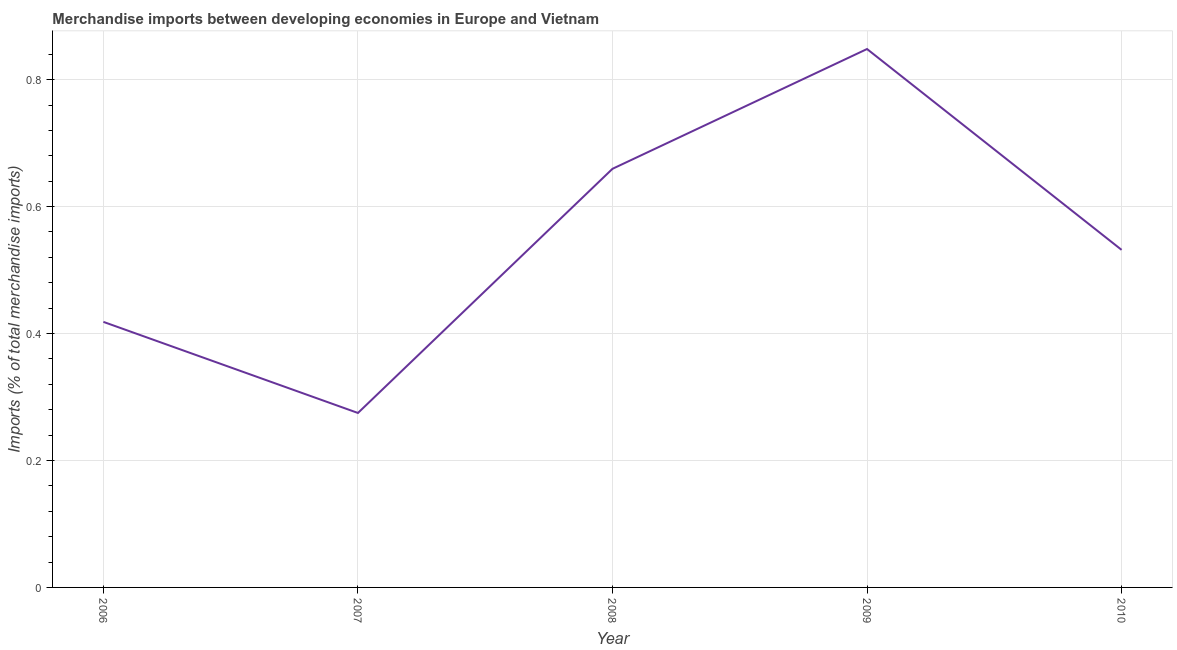What is the merchandise imports in 2009?
Make the answer very short. 0.85. Across all years, what is the maximum merchandise imports?
Give a very brief answer. 0.85. Across all years, what is the minimum merchandise imports?
Make the answer very short. 0.27. What is the sum of the merchandise imports?
Provide a short and direct response. 2.73. What is the difference between the merchandise imports in 2006 and 2009?
Give a very brief answer. -0.43. What is the average merchandise imports per year?
Your answer should be compact. 0.55. What is the median merchandise imports?
Your answer should be very brief. 0.53. In how many years, is the merchandise imports greater than 0.7200000000000001 %?
Offer a terse response. 1. Do a majority of the years between 2009 and 2010 (inclusive) have merchandise imports greater than 0.68 %?
Ensure brevity in your answer.  No. What is the ratio of the merchandise imports in 2008 to that in 2010?
Offer a terse response. 1.24. Is the difference between the merchandise imports in 2006 and 2007 greater than the difference between any two years?
Make the answer very short. No. What is the difference between the highest and the second highest merchandise imports?
Provide a short and direct response. 0.19. Is the sum of the merchandise imports in 2006 and 2010 greater than the maximum merchandise imports across all years?
Your answer should be very brief. Yes. What is the difference between the highest and the lowest merchandise imports?
Make the answer very short. 0.57. How many lines are there?
Make the answer very short. 1. How many years are there in the graph?
Provide a short and direct response. 5. Are the values on the major ticks of Y-axis written in scientific E-notation?
Make the answer very short. No. Does the graph contain any zero values?
Your answer should be very brief. No. What is the title of the graph?
Your response must be concise. Merchandise imports between developing economies in Europe and Vietnam. What is the label or title of the Y-axis?
Your answer should be compact. Imports (% of total merchandise imports). What is the Imports (% of total merchandise imports) in 2006?
Your answer should be compact. 0.42. What is the Imports (% of total merchandise imports) in 2007?
Offer a very short reply. 0.27. What is the Imports (% of total merchandise imports) in 2008?
Give a very brief answer. 0.66. What is the Imports (% of total merchandise imports) in 2009?
Ensure brevity in your answer.  0.85. What is the Imports (% of total merchandise imports) in 2010?
Provide a succinct answer. 0.53. What is the difference between the Imports (% of total merchandise imports) in 2006 and 2007?
Your response must be concise. 0.14. What is the difference between the Imports (% of total merchandise imports) in 2006 and 2008?
Make the answer very short. -0.24. What is the difference between the Imports (% of total merchandise imports) in 2006 and 2009?
Make the answer very short. -0.43. What is the difference between the Imports (% of total merchandise imports) in 2006 and 2010?
Provide a short and direct response. -0.11. What is the difference between the Imports (% of total merchandise imports) in 2007 and 2008?
Ensure brevity in your answer.  -0.38. What is the difference between the Imports (% of total merchandise imports) in 2007 and 2009?
Your answer should be compact. -0.57. What is the difference between the Imports (% of total merchandise imports) in 2007 and 2010?
Keep it short and to the point. -0.26. What is the difference between the Imports (% of total merchandise imports) in 2008 and 2009?
Provide a succinct answer. -0.19. What is the difference between the Imports (% of total merchandise imports) in 2008 and 2010?
Provide a short and direct response. 0.13. What is the difference between the Imports (% of total merchandise imports) in 2009 and 2010?
Keep it short and to the point. 0.32. What is the ratio of the Imports (% of total merchandise imports) in 2006 to that in 2007?
Your answer should be compact. 1.52. What is the ratio of the Imports (% of total merchandise imports) in 2006 to that in 2008?
Ensure brevity in your answer.  0.63. What is the ratio of the Imports (% of total merchandise imports) in 2006 to that in 2009?
Make the answer very short. 0.49. What is the ratio of the Imports (% of total merchandise imports) in 2006 to that in 2010?
Your response must be concise. 0.79. What is the ratio of the Imports (% of total merchandise imports) in 2007 to that in 2008?
Keep it short and to the point. 0.42. What is the ratio of the Imports (% of total merchandise imports) in 2007 to that in 2009?
Keep it short and to the point. 0.32. What is the ratio of the Imports (% of total merchandise imports) in 2007 to that in 2010?
Offer a terse response. 0.52. What is the ratio of the Imports (% of total merchandise imports) in 2008 to that in 2009?
Your answer should be compact. 0.78. What is the ratio of the Imports (% of total merchandise imports) in 2008 to that in 2010?
Your answer should be very brief. 1.24. What is the ratio of the Imports (% of total merchandise imports) in 2009 to that in 2010?
Give a very brief answer. 1.59. 